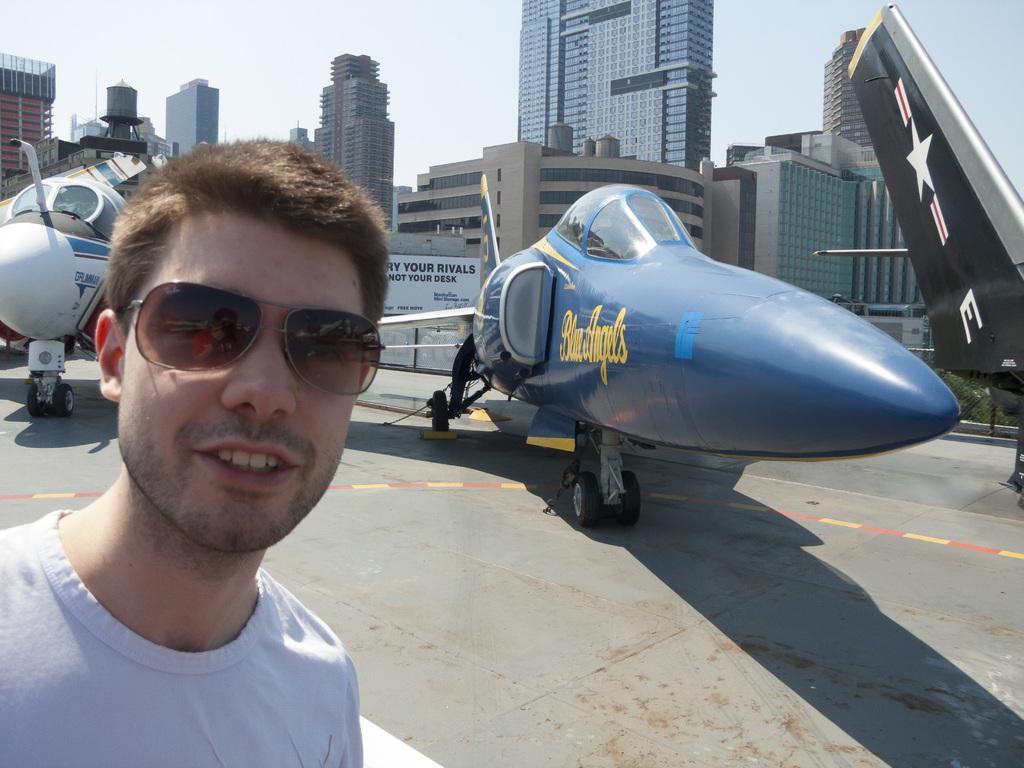Describe this image in one or two sentences. In this picture we can see a man in the front, there are two aircraft here, in the background there are some buildings, we can see the sky at the top of the picture, this man wore goggles. 